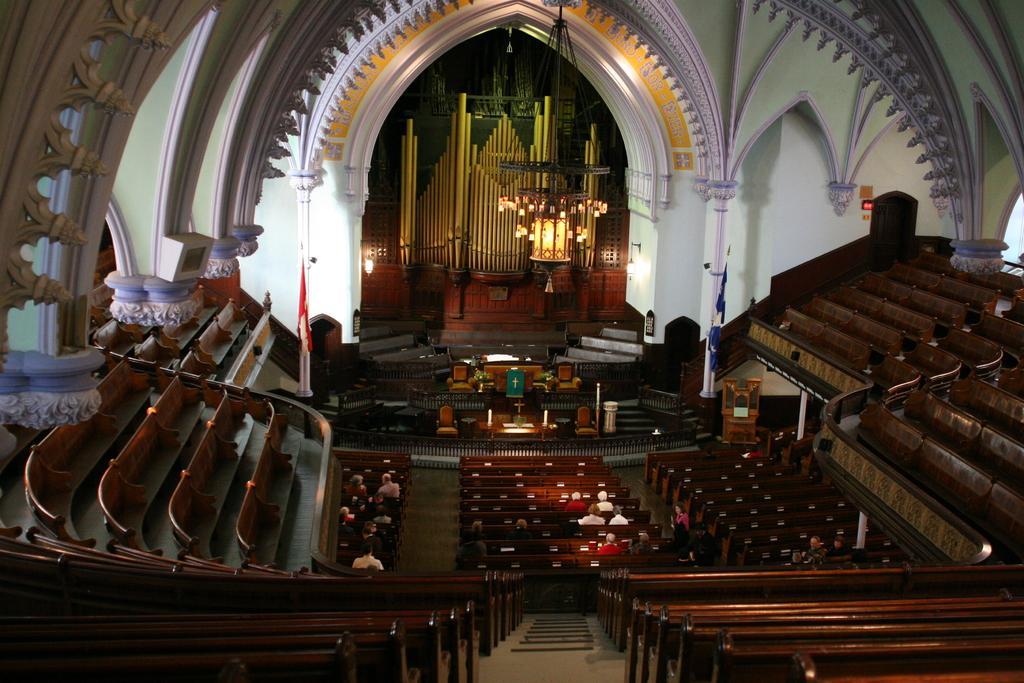Could you give a brief overview of what you see in this image? In this image I can see few benches which are brown in color, the aisle and number of persons are sitting on the benches. In the background I can see the building, few lights, few candles, few chairs, the white colored wall and a chandelier. 